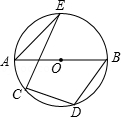Can you explain why angle AEB is 90 degrees? Certainly! In circle geometry, when you have a diameter line like AB in a circle, any triangle formed by this diameter and another point on the circle, such as point E, will always have a right angle (90 degrees) opposite the diameter. This is a consequence of the Inscribed Angle Theorem, illustrating a fundamental property of circles. 